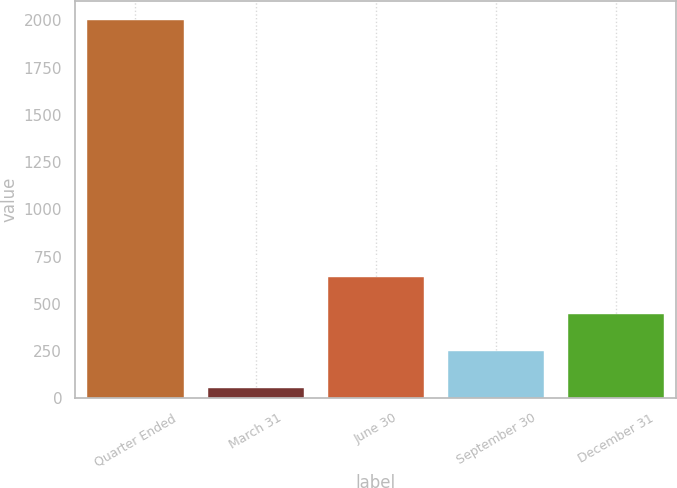<chart> <loc_0><loc_0><loc_500><loc_500><bar_chart><fcel>Quarter Ended<fcel>March 31<fcel>June 30<fcel>September 30<fcel>December 31<nl><fcel>2003<fcel>55.75<fcel>639.93<fcel>250.48<fcel>445.21<nl></chart> 